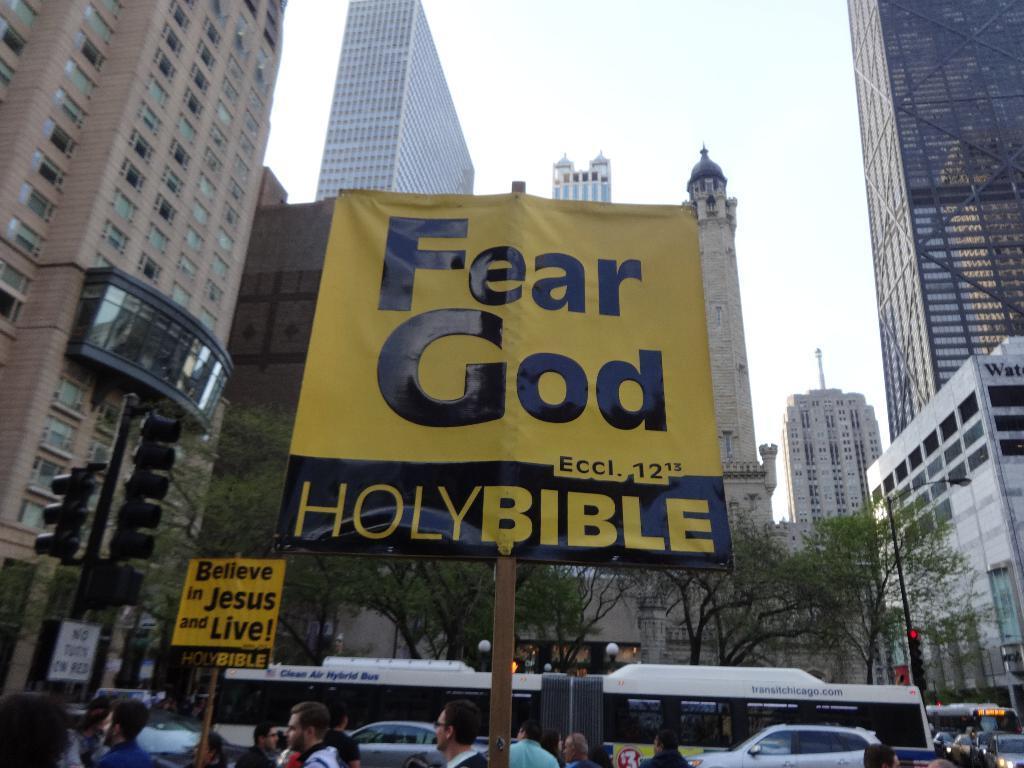Please provide a concise description of this image. In the foreground of the picture there are trees, vehicles, people, placards and other objects. On the left there are buildings, signal light. In the middle there are buildings. On the right there are buildings. At the top there is sky. 